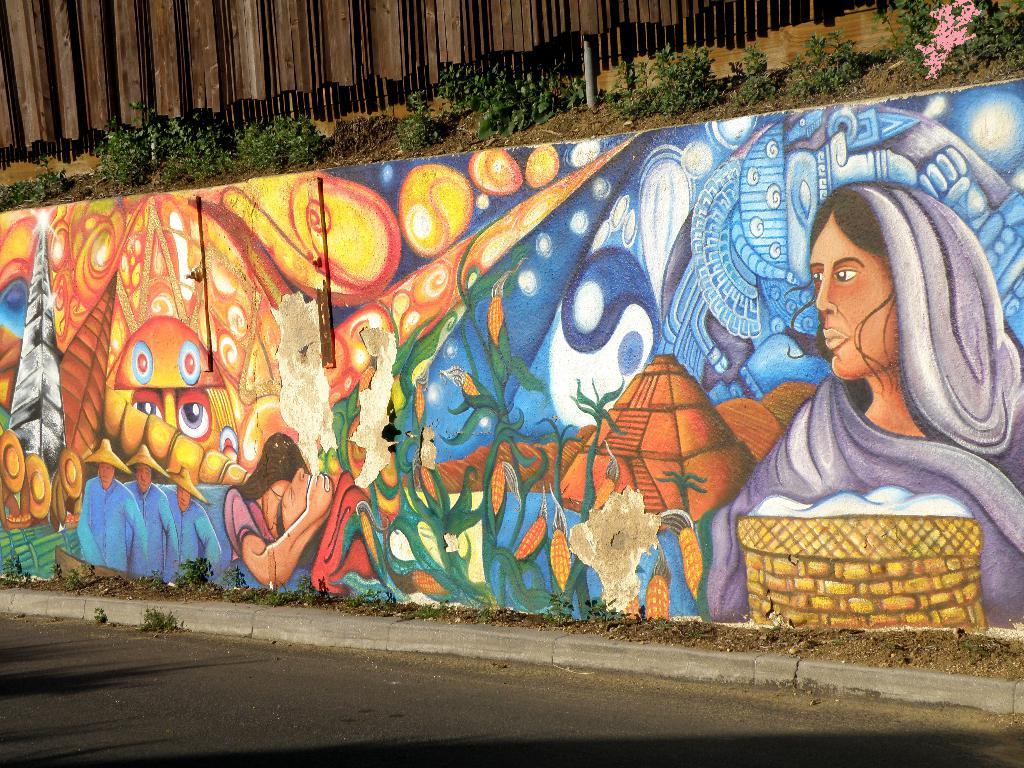What is present on the wall in the image? There are beautiful paintings on the wall. Can you describe the surroundings of the wall? There are small plants above the wall. What type of smoke can be seen coming from the paintings in the image? There is no smoke present in the image; it features a wall with beautiful paintings and small plants above it. 